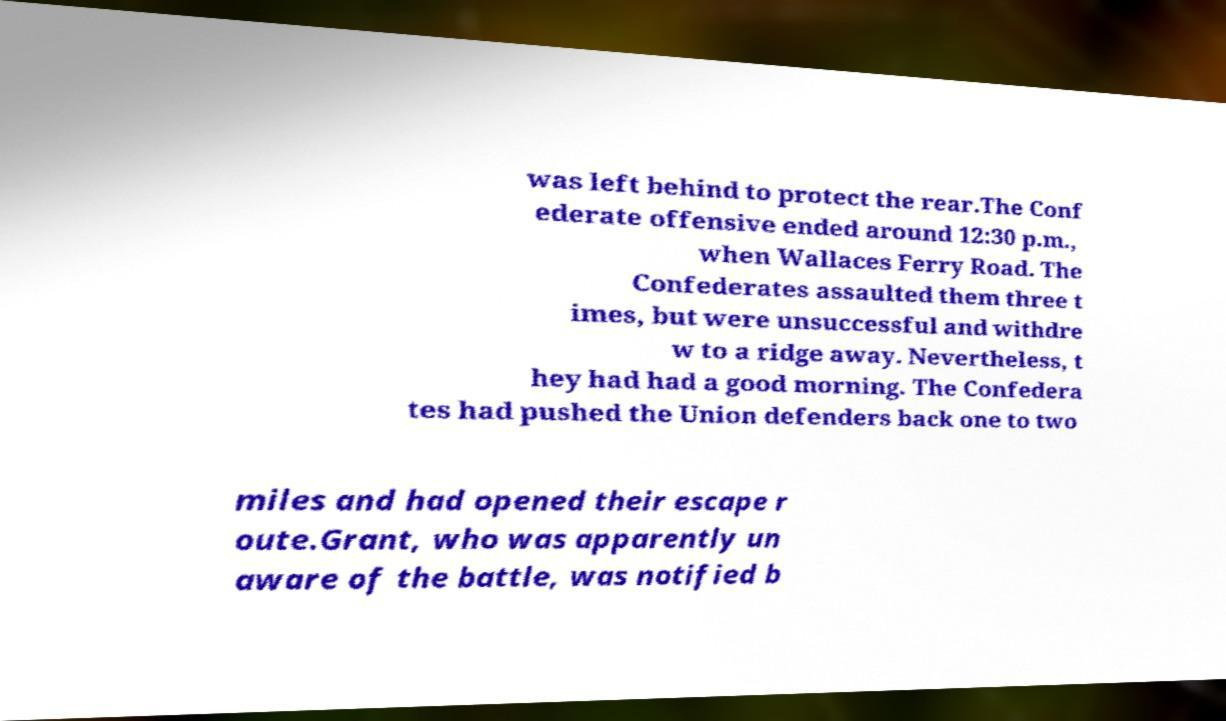There's text embedded in this image that I need extracted. Can you transcribe it verbatim? was left behind to protect the rear.The Conf ederate offensive ended around 12:30 p.m., when Wallaces Ferry Road. The Confederates assaulted them three t imes, but were unsuccessful and withdre w to a ridge away. Nevertheless, t hey had had a good morning. The Confedera tes had pushed the Union defenders back one to two miles and had opened their escape r oute.Grant, who was apparently un aware of the battle, was notified b 